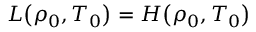<formula> <loc_0><loc_0><loc_500><loc_500>L \, \left ( \rho _ { 0 } , T _ { 0 } \right ) = H \, \left ( \rho _ { 0 } , T _ { 0 } \right )</formula> 